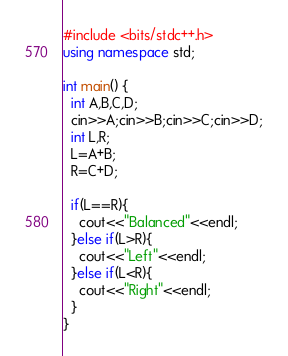Convert code to text. <code><loc_0><loc_0><loc_500><loc_500><_C++_>#include <bits/stdc++.h>
using namespace std;

int main() {
  int A,B,C,D;
  cin>>A;cin>>B;cin>>C;cin>>D;
  int L,R;
  L=A+B;
  R=C+D;

  if(L==R){
    cout<<"Balanced"<<endl;
  }else if(L>R){
    cout<<"Left"<<endl;
  }else if(L<R){
    cout<<"Right"<<endl;
  }
}
</code> 